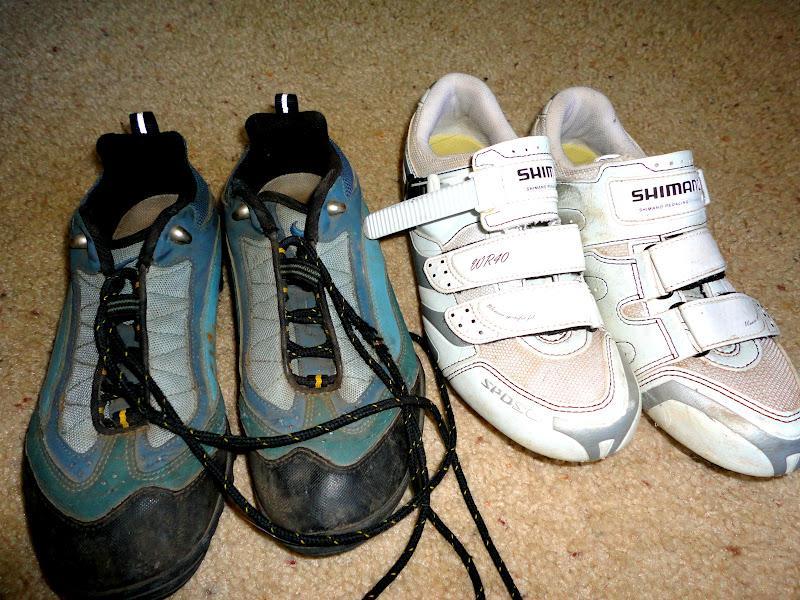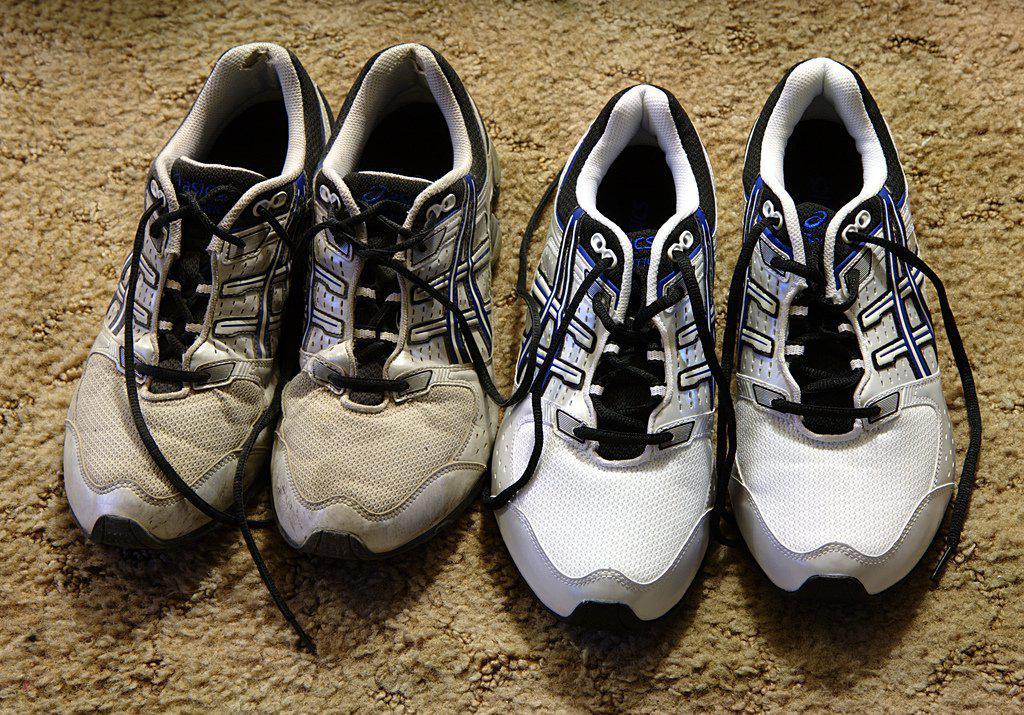The first image is the image on the left, the second image is the image on the right. Examine the images to the left and right. Is the description "Someone is wearing the shoes in one of the images." accurate? Answer yes or no. No. The first image is the image on the left, the second image is the image on the right. Assess this claim about the two images: "In one of the images, a pair of shoes with a white sole are modelled by a human.". Correct or not? Answer yes or no. No. 